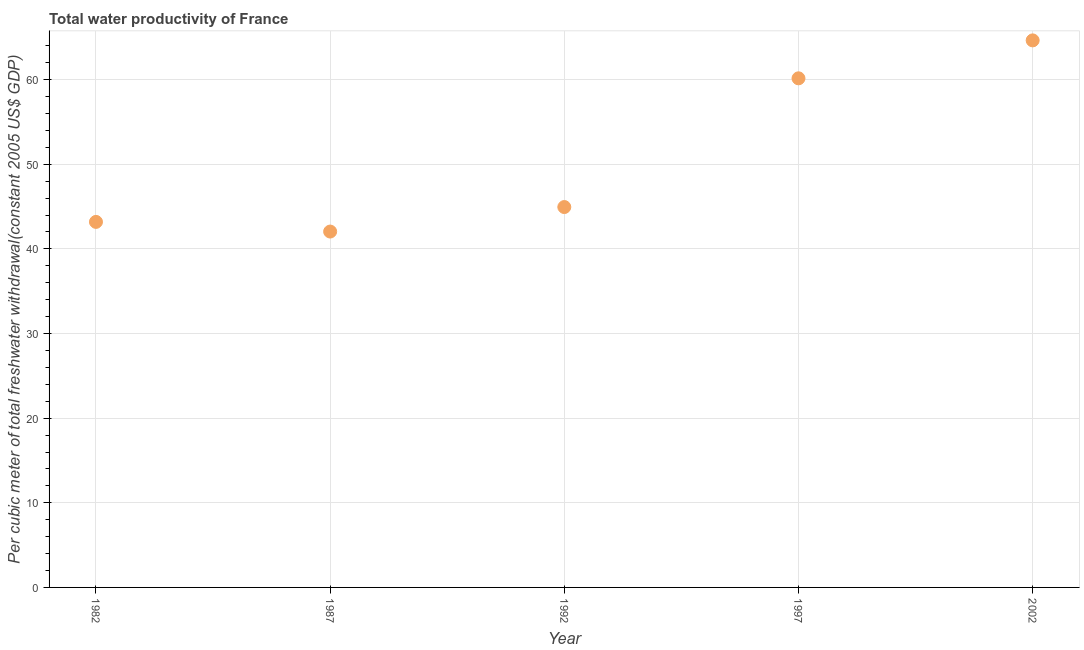What is the total water productivity in 1992?
Your answer should be very brief. 44.94. Across all years, what is the maximum total water productivity?
Offer a very short reply. 64.63. Across all years, what is the minimum total water productivity?
Keep it short and to the point. 42.05. What is the sum of the total water productivity?
Offer a terse response. 254.96. What is the difference between the total water productivity in 1987 and 1997?
Give a very brief answer. -18.11. What is the average total water productivity per year?
Offer a very short reply. 50.99. What is the median total water productivity?
Provide a succinct answer. 44.94. What is the ratio of the total water productivity in 1992 to that in 1997?
Keep it short and to the point. 0.75. What is the difference between the highest and the second highest total water productivity?
Offer a very short reply. 4.48. Is the sum of the total water productivity in 1982 and 1987 greater than the maximum total water productivity across all years?
Provide a succinct answer. Yes. What is the difference between the highest and the lowest total water productivity?
Your answer should be very brief. 22.59. In how many years, is the total water productivity greater than the average total water productivity taken over all years?
Give a very brief answer. 2. Does the total water productivity monotonically increase over the years?
Provide a succinct answer. No. How many dotlines are there?
Your answer should be very brief. 1. How many years are there in the graph?
Keep it short and to the point. 5. What is the difference between two consecutive major ticks on the Y-axis?
Offer a terse response. 10. Are the values on the major ticks of Y-axis written in scientific E-notation?
Ensure brevity in your answer.  No. Does the graph contain any zero values?
Make the answer very short. No. What is the title of the graph?
Offer a very short reply. Total water productivity of France. What is the label or title of the Y-axis?
Offer a terse response. Per cubic meter of total freshwater withdrawal(constant 2005 US$ GDP). What is the Per cubic meter of total freshwater withdrawal(constant 2005 US$ GDP) in 1982?
Offer a terse response. 43.19. What is the Per cubic meter of total freshwater withdrawal(constant 2005 US$ GDP) in 1987?
Keep it short and to the point. 42.05. What is the Per cubic meter of total freshwater withdrawal(constant 2005 US$ GDP) in 1992?
Ensure brevity in your answer.  44.94. What is the Per cubic meter of total freshwater withdrawal(constant 2005 US$ GDP) in 1997?
Offer a very short reply. 60.15. What is the Per cubic meter of total freshwater withdrawal(constant 2005 US$ GDP) in 2002?
Make the answer very short. 64.63. What is the difference between the Per cubic meter of total freshwater withdrawal(constant 2005 US$ GDP) in 1982 and 1987?
Your answer should be compact. 1.14. What is the difference between the Per cubic meter of total freshwater withdrawal(constant 2005 US$ GDP) in 1982 and 1992?
Provide a short and direct response. -1.75. What is the difference between the Per cubic meter of total freshwater withdrawal(constant 2005 US$ GDP) in 1982 and 1997?
Give a very brief answer. -16.96. What is the difference between the Per cubic meter of total freshwater withdrawal(constant 2005 US$ GDP) in 1982 and 2002?
Offer a terse response. -21.45. What is the difference between the Per cubic meter of total freshwater withdrawal(constant 2005 US$ GDP) in 1987 and 1992?
Give a very brief answer. -2.9. What is the difference between the Per cubic meter of total freshwater withdrawal(constant 2005 US$ GDP) in 1987 and 1997?
Offer a very short reply. -18.11. What is the difference between the Per cubic meter of total freshwater withdrawal(constant 2005 US$ GDP) in 1987 and 2002?
Your response must be concise. -22.59. What is the difference between the Per cubic meter of total freshwater withdrawal(constant 2005 US$ GDP) in 1992 and 1997?
Offer a very short reply. -15.21. What is the difference between the Per cubic meter of total freshwater withdrawal(constant 2005 US$ GDP) in 1992 and 2002?
Keep it short and to the point. -19.69. What is the difference between the Per cubic meter of total freshwater withdrawal(constant 2005 US$ GDP) in 1997 and 2002?
Provide a short and direct response. -4.48. What is the ratio of the Per cubic meter of total freshwater withdrawal(constant 2005 US$ GDP) in 1982 to that in 1987?
Give a very brief answer. 1.03. What is the ratio of the Per cubic meter of total freshwater withdrawal(constant 2005 US$ GDP) in 1982 to that in 1992?
Ensure brevity in your answer.  0.96. What is the ratio of the Per cubic meter of total freshwater withdrawal(constant 2005 US$ GDP) in 1982 to that in 1997?
Offer a terse response. 0.72. What is the ratio of the Per cubic meter of total freshwater withdrawal(constant 2005 US$ GDP) in 1982 to that in 2002?
Keep it short and to the point. 0.67. What is the ratio of the Per cubic meter of total freshwater withdrawal(constant 2005 US$ GDP) in 1987 to that in 1992?
Give a very brief answer. 0.94. What is the ratio of the Per cubic meter of total freshwater withdrawal(constant 2005 US$ GDP) in 1987 to that in 1997?
Give a very brief answer. 0.7. What is the ratio of the Per cubic meter of total freshwater withdrawal(constant 2005 US$ GDP) in 1987 to that in 2002?
Make the answer very short. 0.65. What is the ratio of the Per cubic meter of total freshwater withdrawal(constant 2005 US$ GDP) in 1992 to that in 1997?
Offer a very short reply. 0.75. What is the ratio of the Per cubic meter of total freshwater withdrawal(constant 2005 US$ GDP) in 1992 to that in 2002?
Give a very brief answer. 0.69. 